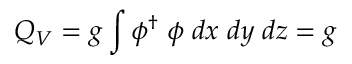Convert formula to latex. <formula><loc_0><loc_0><loc_500><loc_500>Q _ { V } = g \int \phi ^ { \dagger } \, \phi \, d x \, d y \, d z = g</formula> 